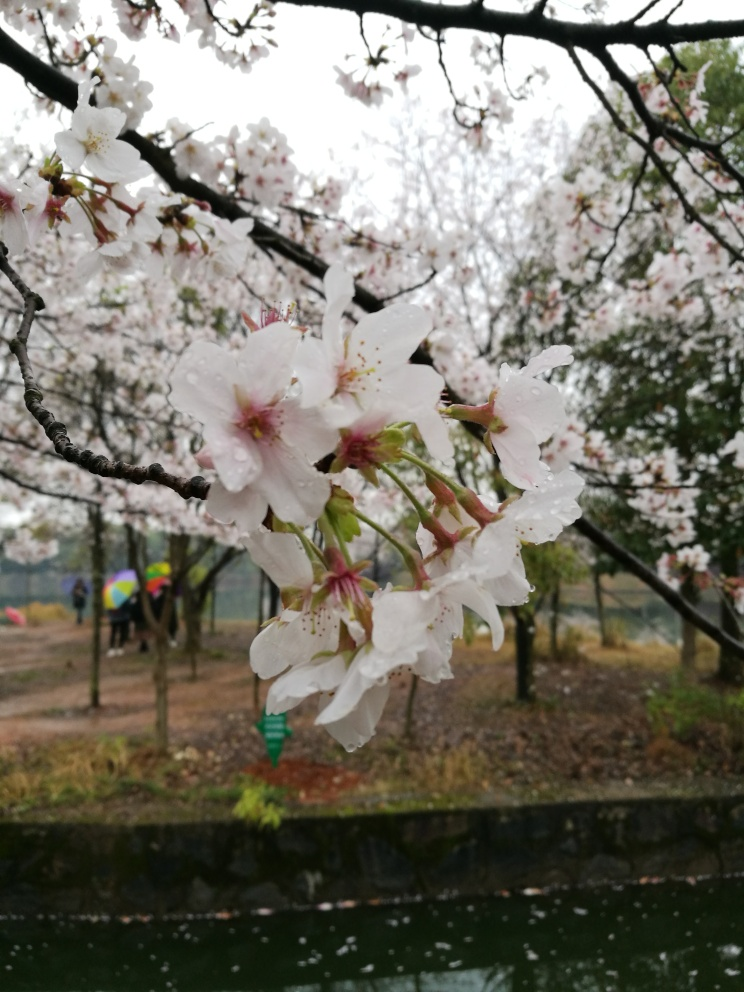Could you tell me more about the location depicted in the image? While the specific location is not identifiable, the image shows a park-like setting with cherry blossoms, which are commonly found in East Asian countries. The presence of a water body and the attire of the individuals holding umbrellas suggest a public space likely frequented for leisure and enjoyment, especially during the blossoming season. 